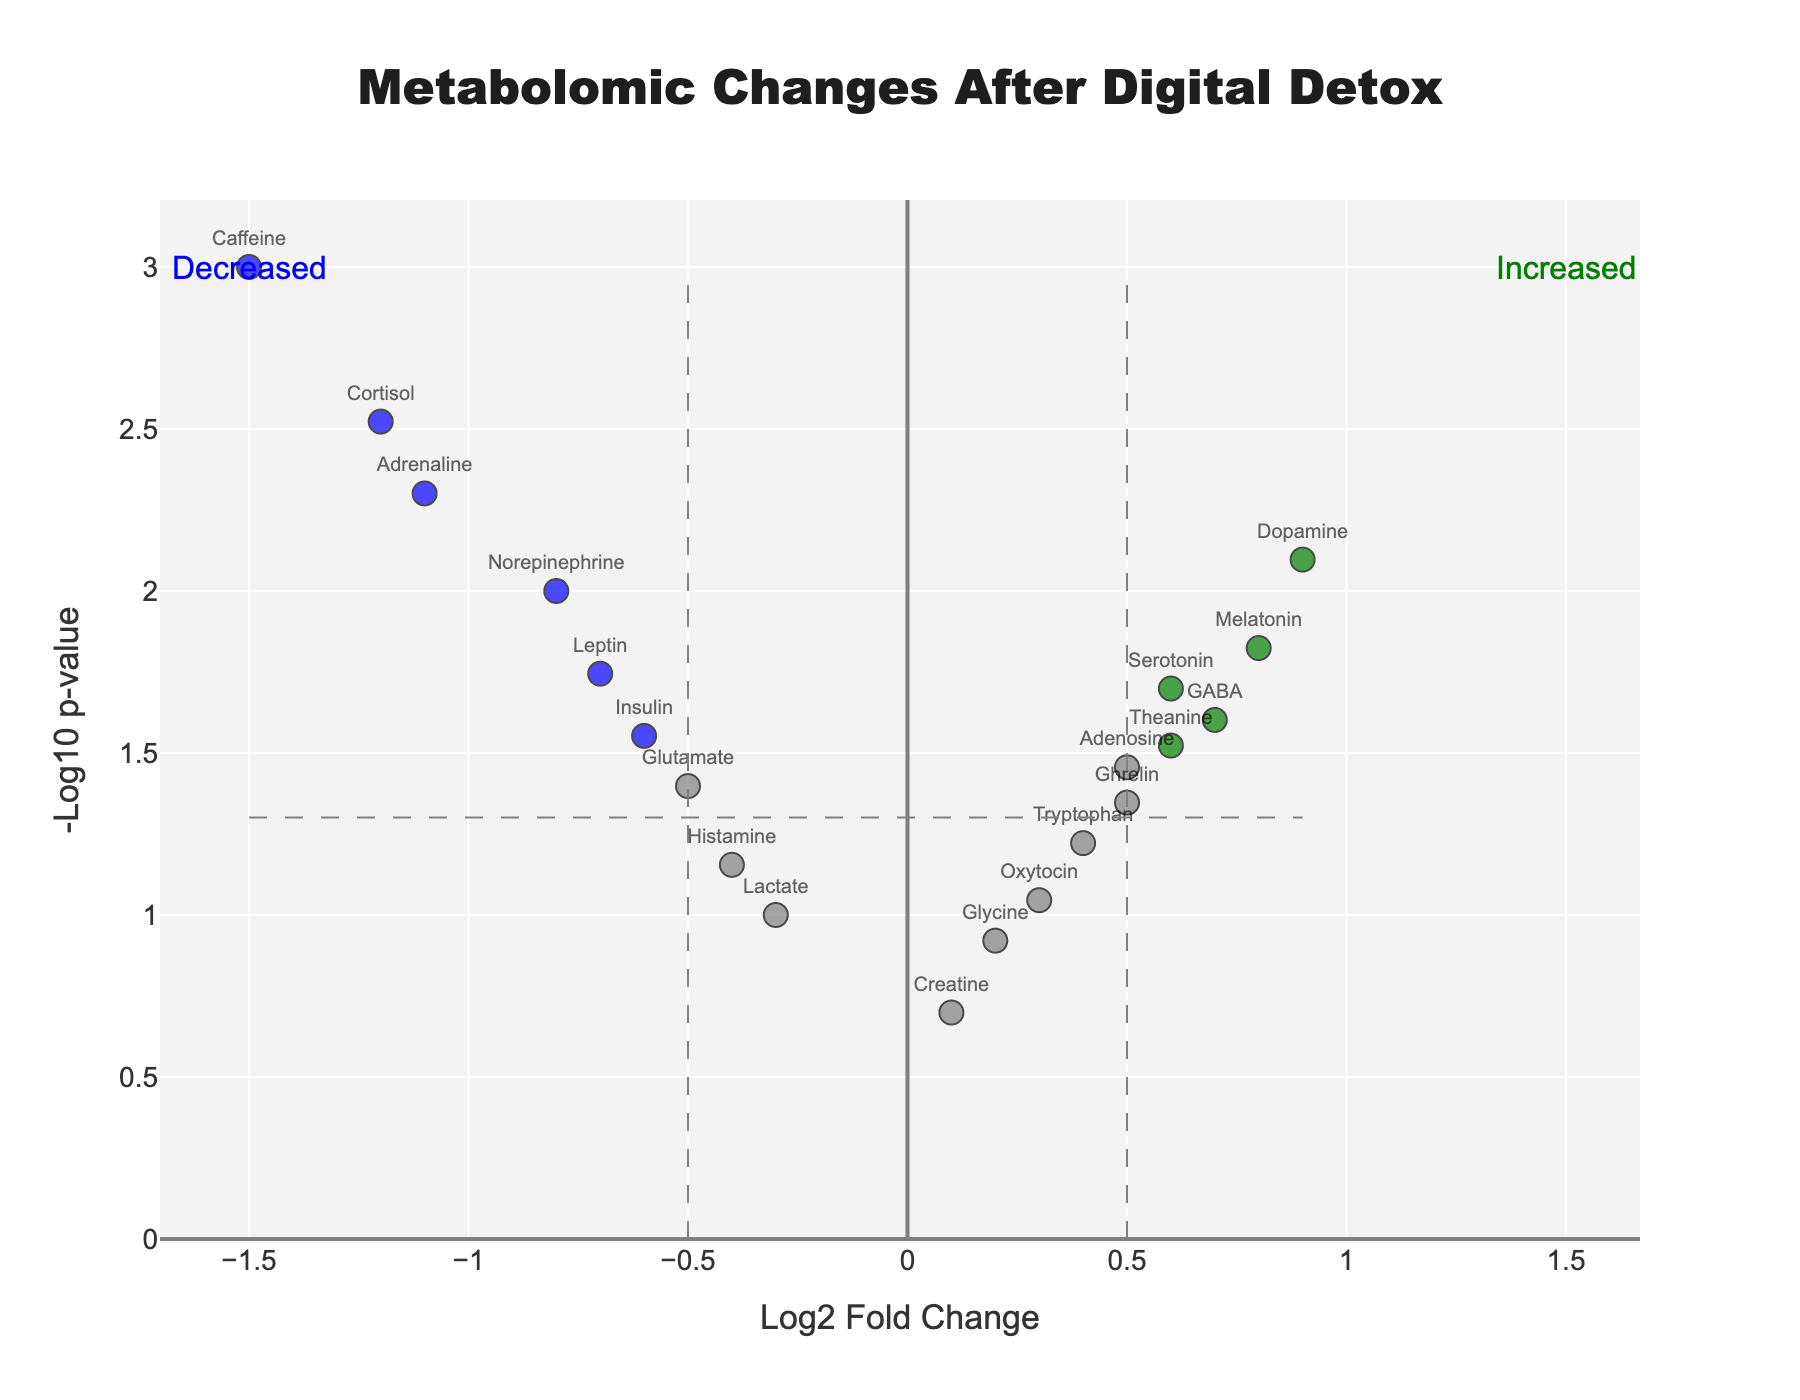How many metabolites show statistically significant changes after the digital detox program? Look for data points colored either green, blue, or red, which indicate a significant change (p-value < 0.05). Count these colored points.
Answer: 12 Which metabolite has the highest fold change? Identify the point with the maximum value on the x-axis (Log2 Fold Change). Hover over to see the metabolite name.
Answer: Caffeine Which metabolites are significantly decreased after the detox program? Look for points on the left side of the x-axis (negative Log2 Fold Change) with a color indicating significance (p-value < 0.05). Identify their names.
Answer: Cortisol, Norepinephrine, Adrenaline, Caffeine, Glutamate, Leptin, Insulin What is the p-value threshold for significance in this plot? The significance threshold is shown as a horizontal line on the y-axis where -Log10(p-value) is calculated. Hover over this line to find the corresponding p-value.
Answer: 0.05 Which color represents significantly increased metabolites, and what are their names? Identify the color that corresponds to data points with a p-value < 0.05 and a positive Log2 Fold Change. List these metabolites.
Answer: Green; Melatonin, Serotonin, Dopamine, GABA, Theanine What is the Log2 Fold Change and p-value for Dopamine? Hover over the point representing Dopamine to find the associated Log2 Fold Change and p-value.
Answer: 0.9, 0.008 Are there more metabolites increasing or decreasing after the detox, among those that are statistically significant? Count the number of points on the positively and negatively marked sides of the plot that are colored to indicate significance. Compare the counts.
Answer: More decreasing What does a blue-colored point in the plot indicate? Identify the meaning of the blue color by referring to the color coding indicating significance and the direction of fold change.
Answer: Significantly decreased What is the range of Log2 Fold Change for the metabolites shown in the plot? Determine the minimum and maximum values on the x-axis for all data points.
Answer: -1.5 to 0.9 Is there any metabolite with a Log2 Fold Change between 0.3 and 0.7 that is not statistically significant? Check data points with a Log2 Fold Change within the specified range and determine if their color indicates significance.
Answer: Yes, Tryptophan and Glycine 